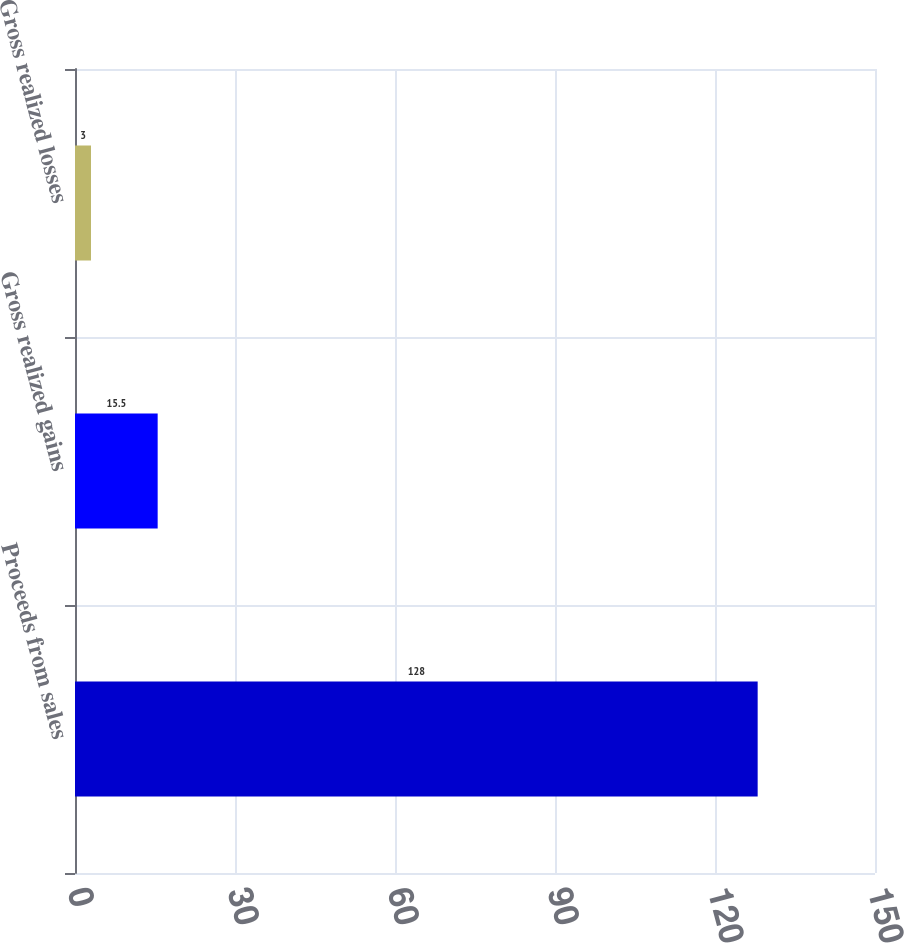Convert chart. <chart><loc_0><loc_0><loc_500><loc_500><bar_chart><fcel>Proceeds from sales<fcel>Gross realized gains<fcel>Gross realized losses<nl><fcel>128<fcel>15.5<fcel>3<nl></chart> 